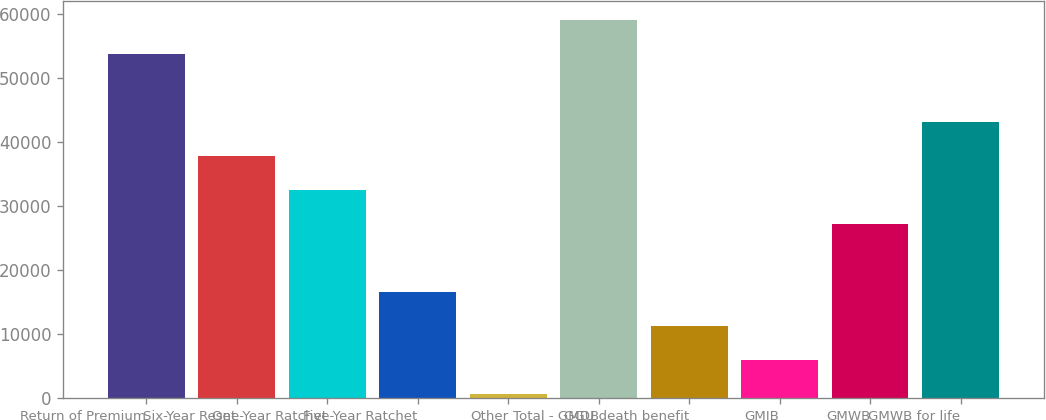<chart> <loc_0><loc_0><loc_500><loc_500><bar_chart><fcel>Return of Premium<fcel>Six-Year Reset<fcel>One-Year Ratchet<fcel>Five-Year Ratchet<fcel>Other<fcel>Total - GMDB<fcel>GGU death benefit<fcel>GMIB<fcel>GMWB<fcel>GMWB for life<nl><fcel>53743<fcel>37794.7<fcel>32478.6<fcel>16530.3<fcel>582<fcel>59059.1<fcel>11214.2<fcel>5898.1<fcel>27162.5<fcel>43110.8<nl></chart> 